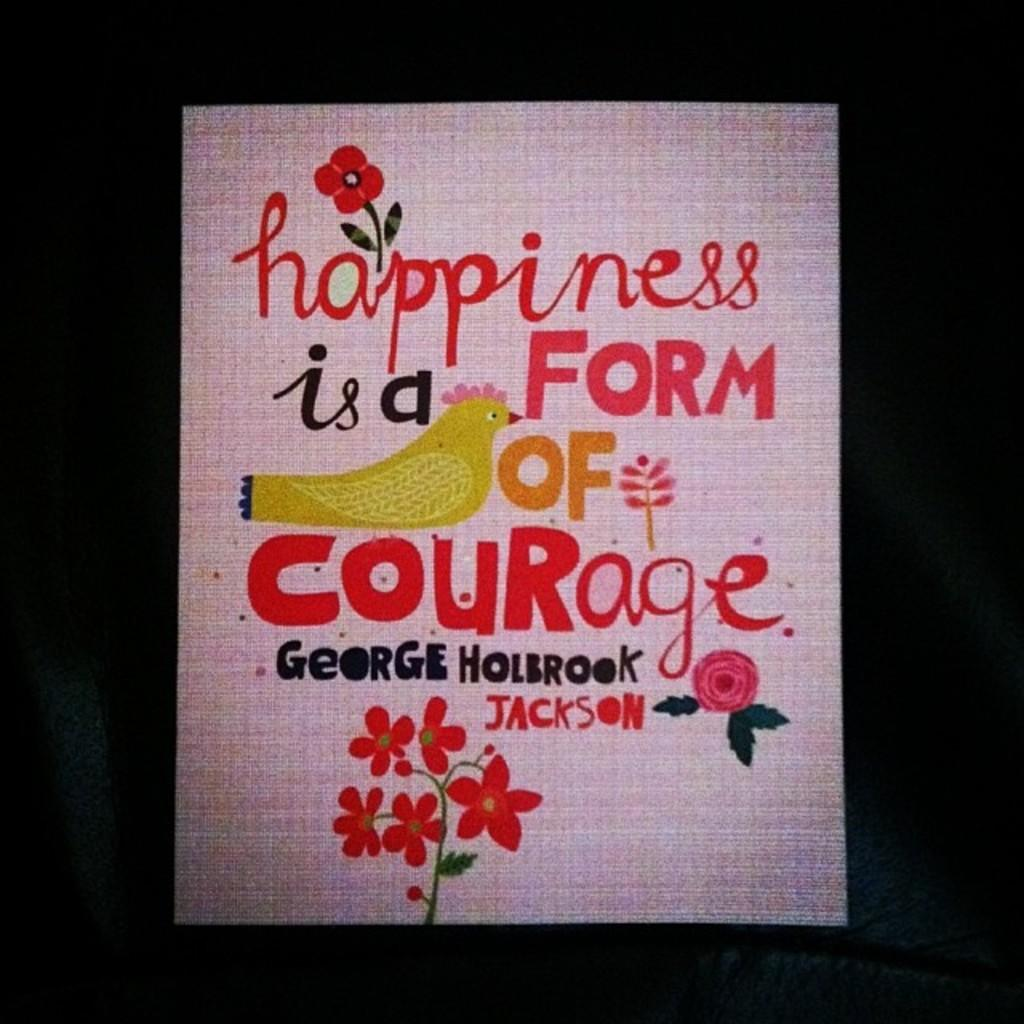What is featured on the poster in the image? The poster contains text and has drawings of flowers and a bird. Can you describe the drawings on the poster? The poster has a drawing of flowers and a bird. What type of crime is being committed in the image? There is no indication of a crime being committed in the image; it features a poster with text and drawings of flowers and a bird. 